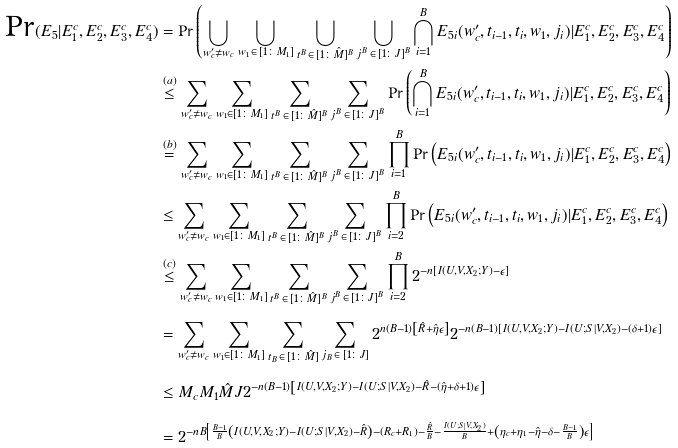Convert formula to latex. <formula><loc_0><loc_0><loc_500><loc_500>\text {Pr} ( E _ { 5 } | E _ { 1 } ^ { c } , E _ { 2 } ^ { c } , E _ { 3 } ^ { c } , E _ { 4 } ^ { c } ) & = \text {Pr} \left ( \bigcup _ { w ^ { \prime } _ { c } \neq w _ { c } } \bigcup _ { w _ { 1 } \, \in \, [ 1 \colon M _ { 1 } ] } \bigcup _ { t ^ { B } \, \in \, [ 1 \colon \hat { M } ] ^ { B } } \bigcup _ { j ^ { B } \, \in \, [ 1 \colon J ] ^ { B } } \bigcap _ { i = 1 } ^ { B } E _ { 5 i } ( w ^ { \prime } _ { c } , t _ { i - 1 } , t _ { i } , w _ { 1 } , j _ { i } ) | E _ { 1 } ^ { c } , E _ { 2 } ^ { c } , E _ { 3 } ^ { c } , E ^ { c } _ { 4 } \right ) \\ & \stackrel { ( a ) } { \leq } \sum _ { w ^ { \prime } _ { c } \neq w _ { c } } \sum _ { w _ { 1 } \in [ 1 \colon M _ { 1 } ] } \sum _ { t ^ { B } \, \in \, [ 1 \colon \hat { M } ] ^ { B } } \sum _ { j ^ { B } \, \in \, [ 1 \colon J ] ^ { B } } \text {Pr} \left ( \bigcap _ { i = 1 } ^ { B } E _ { 5 i } ( w ^ { \prime } _ { c } , t _ { i - 1 } , t _ { i } , w _ { 1 } , j _ { i } ) | E _ { 1 } ^ { c } , E _ { 2 } ^ { c } , E _ { 3 } ^ { c } , E _ { 4 } ^ { c } \right ) \\ & \stackrel { ( b ) } { = } \sum _ { w ^ { \prime } _ { c } \neq w _ { c } } \sum _ { w _ { 1 } \in [ 1 \colon M _ { 1 } ] } \sum _ { t ^ { B } \, \in \, [ 1 \colon \hat { M } ] ^ { B } } \sum _ { j ^ { B } \, \in \, [ 1 \colon J ] ^ { B } } \prod _ { i = 1 } ^ { B } \text {Pr} \left ( E _ { 5 i } ( w ^ { \prime } _ { c } , t _ { i - 1 } , t _ { i } , w _ { 1 } , j _ { i } ) | E _ { 1 } ^ { c } , E _ { 2 } ^ { c } , E _ { 3 } ^ { c } , E ^ { c } _ { 4 } \right ) \\ & \leq \sum _ { w ^ { \prime } _ { c } \neq w _ { c } } \sum _ { w _ { 1 } \in [ 1 \colon M _ { 1 } ] } \sum _ { t ^ { B } \, \in \, [ 1 \colon \hat { M } ] ^ { B } } \sum _ { j ^ { B } \, \in \, [ 1 \colon J ] ^ { B } } \prod _ { i = 2 } ^ { B } \text {Pr} \left ( E _ { 5 i } ( w ^ { \prime } _ { c } , t _ { i - 1 } , t _ { i } , w _ { 1 } , j _ { i } ) | E _ { 1 } ^ { c } , E _ { 2 } ^ { c } , E _ { 3 } ^ { c } , E _ { 4 } ^ { c } \right ) \\ & \stackrel { ( c ) } { \leq } \sum _ { w ^ { \prime } _ { c } \neq w _ { c } } \sum _ { w _ { 1 } \in [ 1 \colon M _ { 1 } ] } \sum _ { t ^ { B } \, \in \, [ 1 \colon \hat { M } ] ^ { B } } \sum _ { j ^ { B } \, \in \, [ 1 \colon J ] ^ { B } } \prod _ { i = 2 } ^ { B } 2 ^ { - n \left [ I ( U , V , X _ { 2 } ; Y ) - \epsilon \right ] } \\ & = \sum _ { w ^ { \prime } _ { c } \neq w _ { c } } \sum _ { w _ { 1 } \in [ 1 \colon M _ { 1 } ] } \sum _ { t _ { B } \, \in \, [ 1 \colon \hat { M } ] } \sum _ { j _ { B } \, \in \, [ 1 \colon J ] } 2 ^ { n ( B - 1 ) \left [ \hat { R } + \hat { \eta } \epsilon \right ] } 2 ^ { - n ( B - 1 ) \left [ I ( U , V , X _ { 2 } ; Y ) - I ( U ; S | V , X _ { 2 } ) - ( \delta + 1 ) \epsilon \right ] } \\ & \leq M _ { c } M _ { 1 } \hat { M } J 2 ^ { - n ( B - 1 ) \left [ I ( U , V , X _ { 2 } ; Y ) - I ( U ; S | V , X _ { 2 } ) - \hat { R } - ( \hat { \eta } + \delta + 1 ) \epsilon \right ] } \\ & = 2 ^ { - n B \left [ \frac { B - 1 } { B } \left ( I ( U , V , X _ { 2 } ; Y ) - I ( U ; S | V , X _ { 2 } ) - \hat { R } \right ) - ( R _ { c } + R _ { 1 } ) - \frac { \hat { R } } { B } - \frac { I ( U ; S | V , X _ { 2 } ) } { B } + \left ( \eta _ { c } + \eta _ { 1 } - \hat { \eta } - \delta - \frac { B - 1 } { B } \right ) \epsilon \right ] }</formula> 